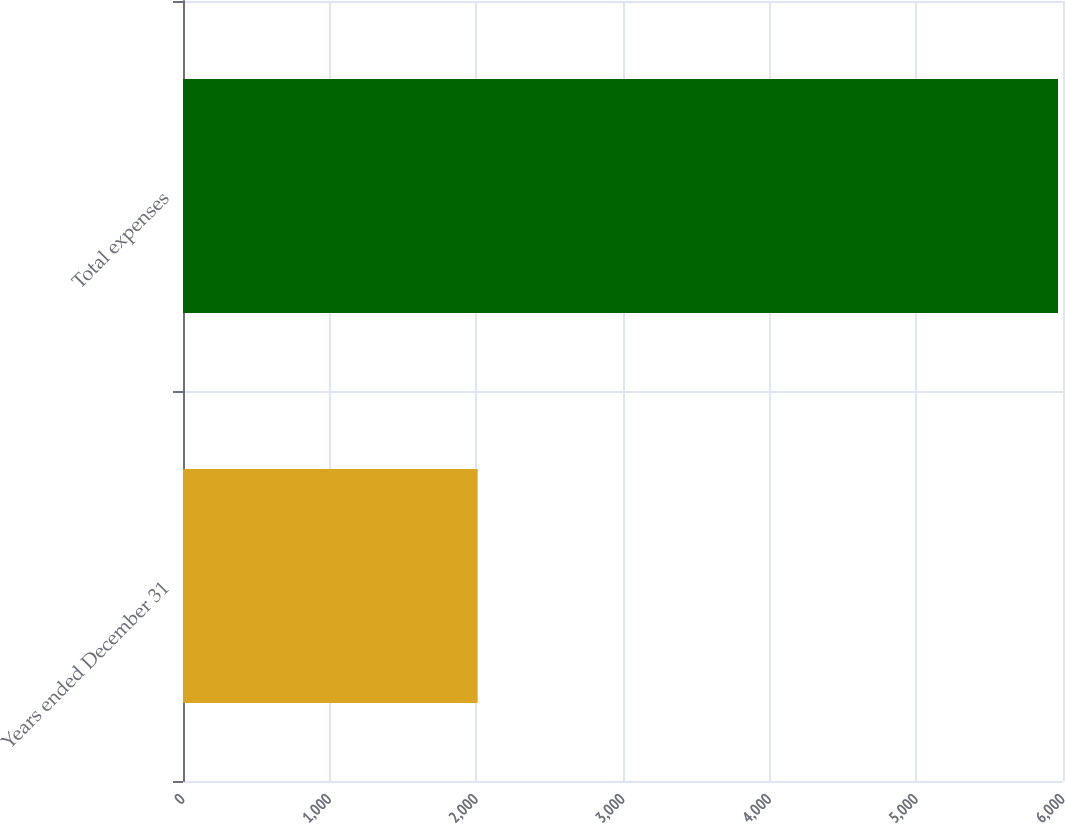Convert chart to OTSL. <chart><loc_0><loc_0><loc_500><loc_500><bar_chart><fcel>Years ended December 31<fcel>Total expenses<nl><fcel>2009<fcel>5966<nl></chart> 